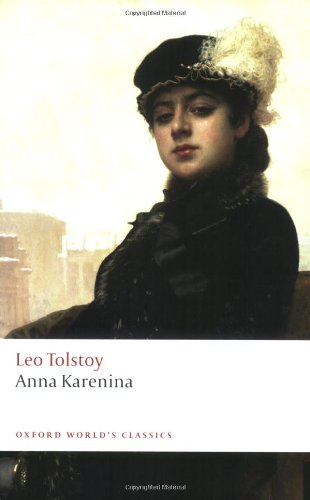Is this book related to Romance? Yes, 'Anna Karenina' has strong elements of romance, focusing on the complexities of love and relationships in a restrictive society, alongside the protagonist's tumultuous affair which centralizes the narrative. 